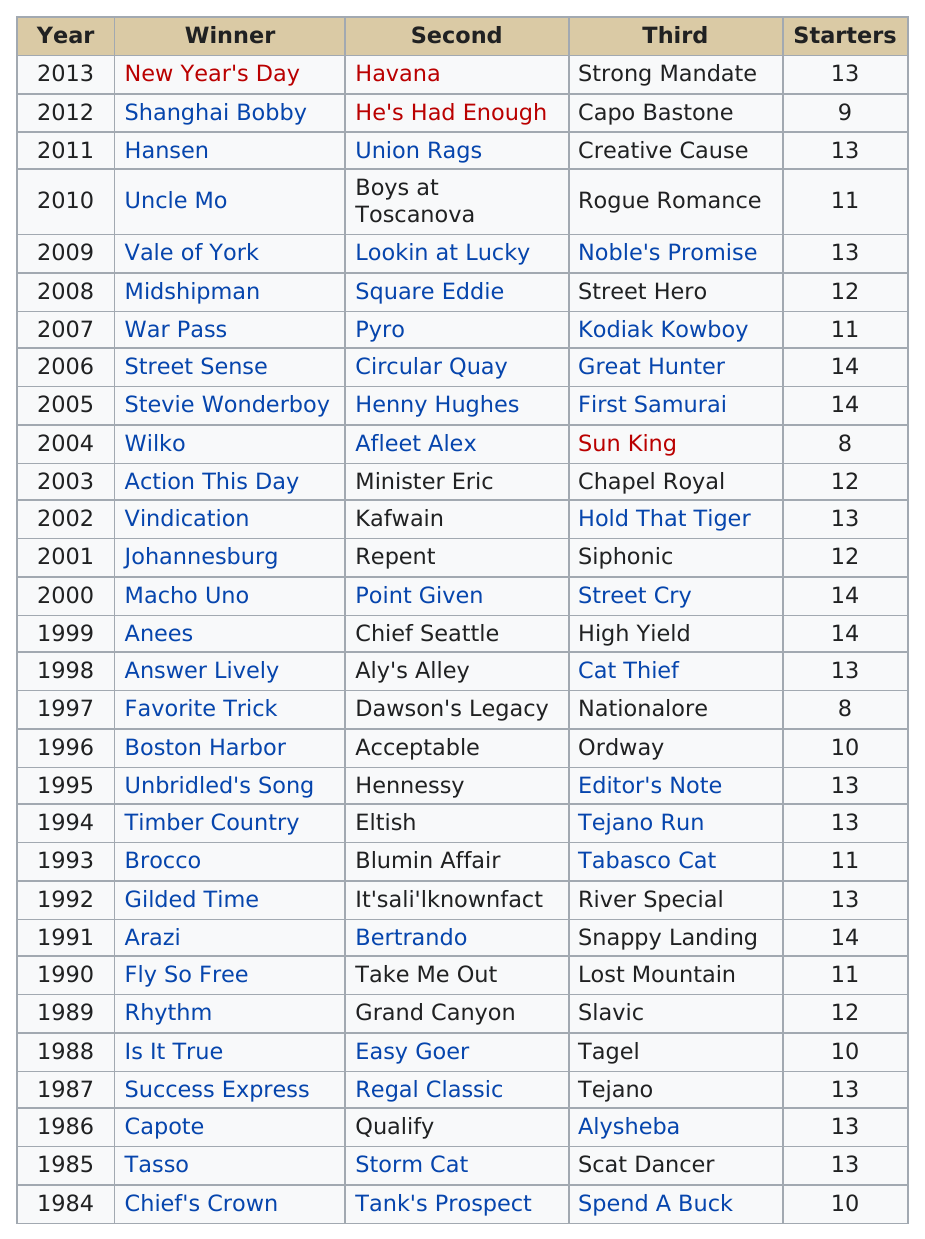Specify some key components in this picture. In 2008, the number of starters was 12. The years 1991, 1999, 2000, 2005, and 2006 had the most starters. There are 11 winners whose names consist of only one word. The horse named Tasso finished first in the Breeders' Cup race in 1985. The name of the person listed before pyro in the second column of the chart is Circular Quay. 